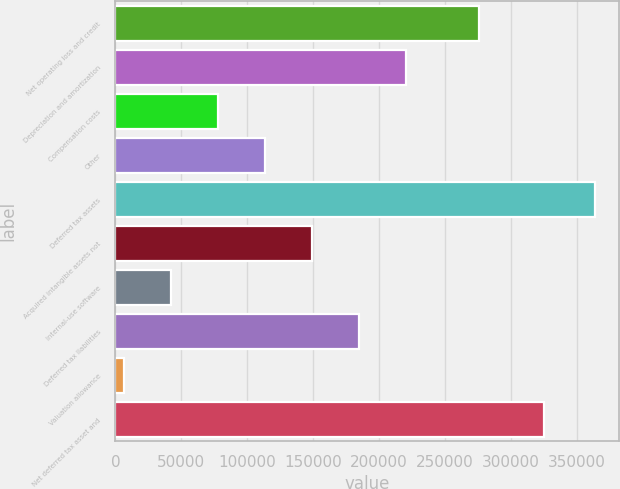<chart> <loc_0><loc_0><loc_500><loc_500><bar_chart><fcel>Net operating loss and credit<fcel>Depreciation and amortization<fcel>Compensation costs<fcel>Other<fcel>Deferred tax assets<fcel>Acquired intangible assets not<fcel>Internal-use software<fcel>Deferred tax liabilities<fcel>Valuation allowance<fcel>Net deferred tax asset and<nl><fcel>275934<fcel>220648<fcel>77774.8<fcel>113493<fcel>363522<fcel>149212<fcel>42056.4<fcel>184930<fcel>6338<fcel>324608<nl></chart> 